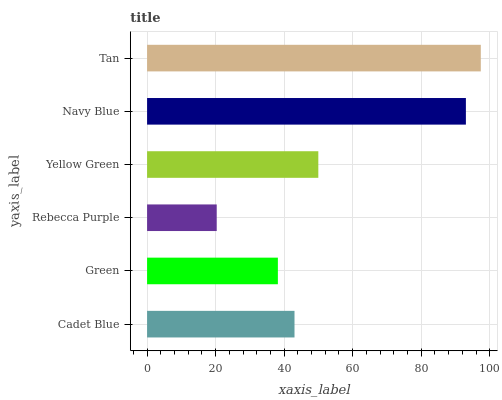Is Rebecca Purple the minimum?
Answer yes or no. Yes. Is Tan the maximum?
Answer yes or no. Yes. Is Green the minimum?
Answer yes or no. No. Is Green the maximum?
Answer yes or no. No. Is Cadet Blue greater than Green?
Answer yes or no. Yes. Is Green less than Cadet Blue?
Answer yes or no. Yes. Is Green greater than Cadet Blue?
Answer yes or no. No. Is Cadet Blue less than Green?
Answer yes or no. No. Is Yellow Green the high median?
Answer yes or no. Yes. Is Cadet Blue the low median?
Answer yes or no. Yes. Is Green the high median?
Answer yes or no. No. Is Green the low median?
Answer yes or no. No. 